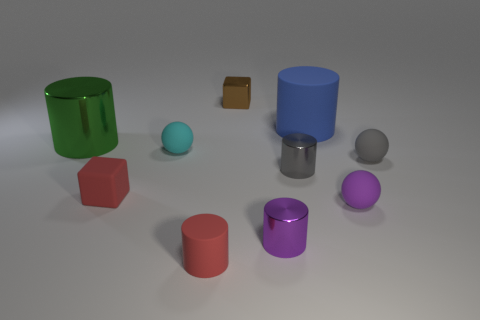Subtract all green cylinders. How many cylinders are left? 4 Subtract all tiny purple balls. How many balls are left? 2 Subtract all red cylinders. How many cyan balls are left? 1 Subtract all cyan matte spheres. Subtract all large blue objects. How many objects are left? 8 Add 8 purple matte spheres. How many purple matte spheres are left? 9 Add 7 gray spheres. How many gray spheres exist? 8 Subtract 1 blue cylinders. How many objects are left? 9 Subtract all balls. How many objects are left? 7 Subtract 2 spheres. How many spheres are left? 1 Subtract all blue cubes. Subtract all cyan cylinders. How many cubes are left? 2 